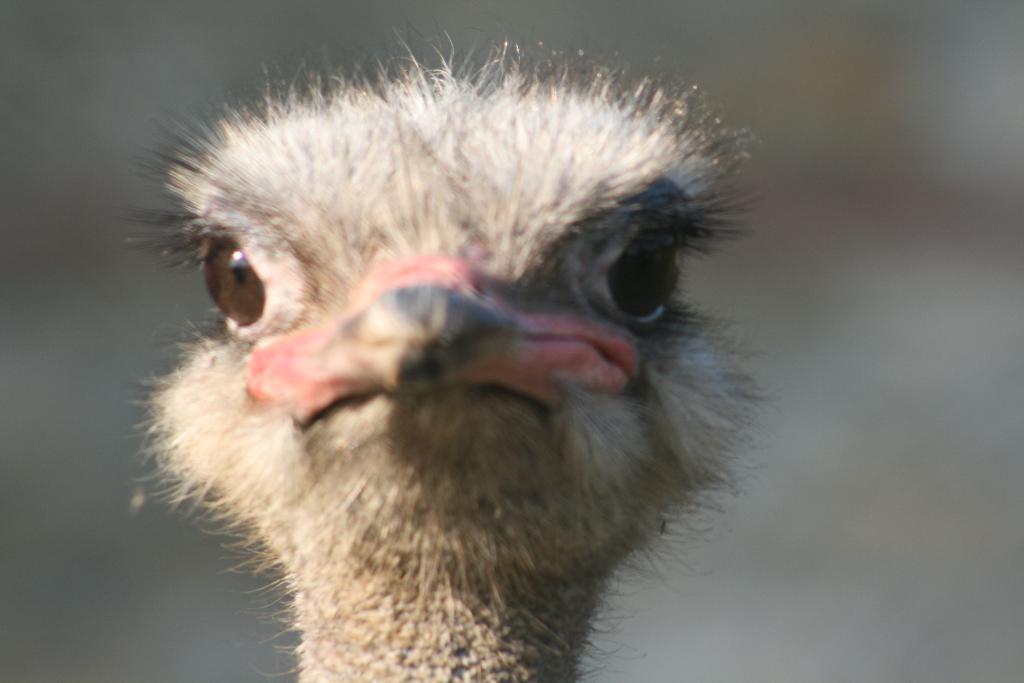Could you give a brief overview of what you see in this image? In the picture there is a head part of some animal is visible, it has a beak and the background of the animal is blur. 